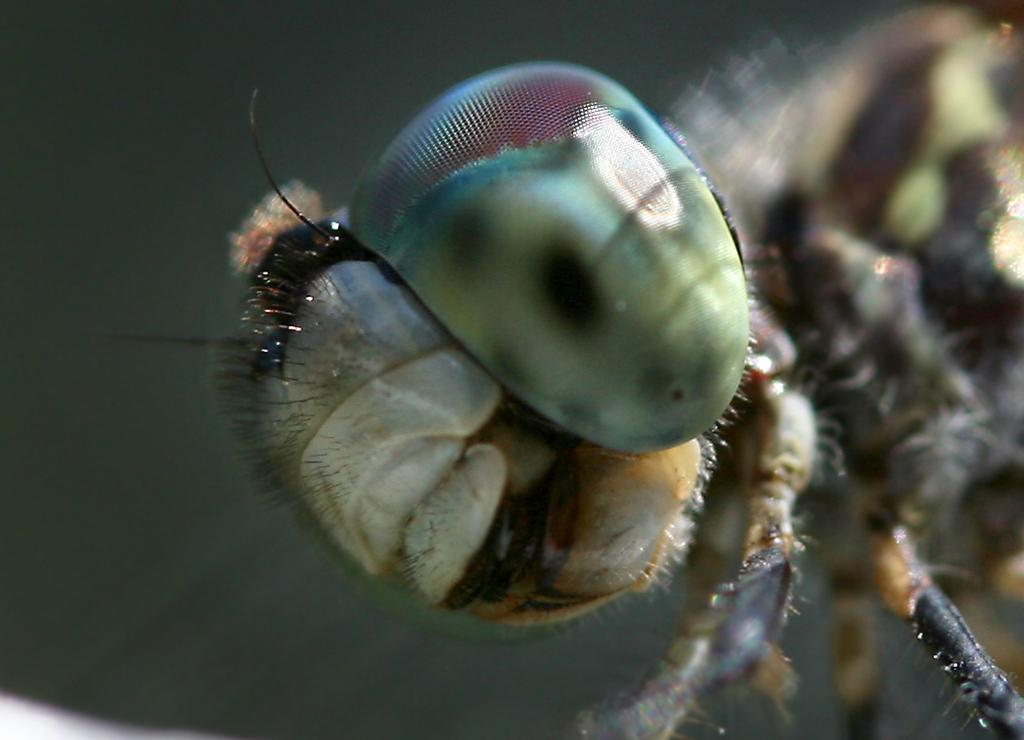What is the main subject of the image? The main subject of the image is a dragonfly. Can you describe the background of the image? The background of the image is blurred. What type of power does the dragonfly have in the image? The image does not depict the dragonfly using any power or abilities; it is simply a closeup view of the insect. 